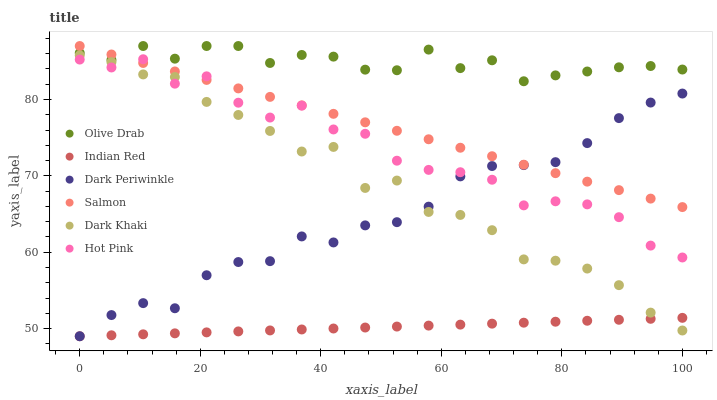Does Indian Red have the minimum area under the curve?
Answer yes or no. Yes. Does Olive Drab have the maximum area under the curve?
Answer yes or no. Yes. Does Salmon have the minimum area under the curve?
Answer yes or no. No. Does Salmon have the maximum area under the curve?
Answer yes or no. No. Is Indian Red the smoothest?
Answer yes or no. Yes. Is Hot Pink the roughest?
Answer yes or no. Yes. Is Salmon the smoothest?
Answer yes or no. No. Is Salmon the roughest?
Answer yes or no. No. Does Indian Red have the lowest value?
Answer yes or no. Yes. Does Salmon have the lowest value?
Answer yes or no. No. Does Olive Drab have the highest value?
Answer yes or no. Yes. Does Dark Khaki have the highest value?
Answer yes or no. No. Is Dark Khaki less than Olive Drab?
Answer yes or no. Yes. Is Salmon greater than Indian Red?
Answer yes or no. Yes. Does Dark Khaki intersect Indian Red?
Answer yes or no. Yes. Is Dark Khaki less than Indian Red?
Answer yes or no. No. Is Dark Khaki greater than Indian Red?
Answer yes or no. No. Does Dark Khaki intersect Olive Drab?
Answer yes or no. No. 